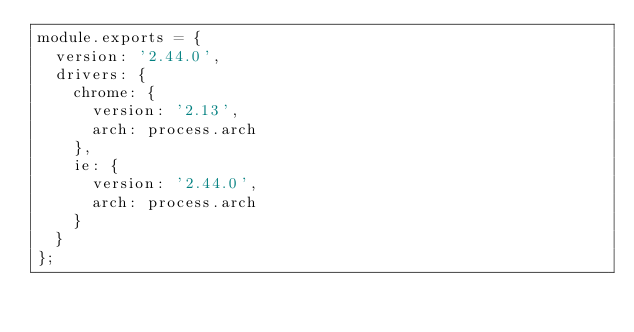Convert code to text. <code><loc_0><loc_0><loc_500><loc_500><_JavaScript_>module.exports = {
  version: '2.44.0',
  drivers: {
    chrome: {
      version: '2.13',
      arch: process.arch
    },
    ie: {
      version: '2.44.0',
      arch: process.arch
    }
  }
};
</code> 